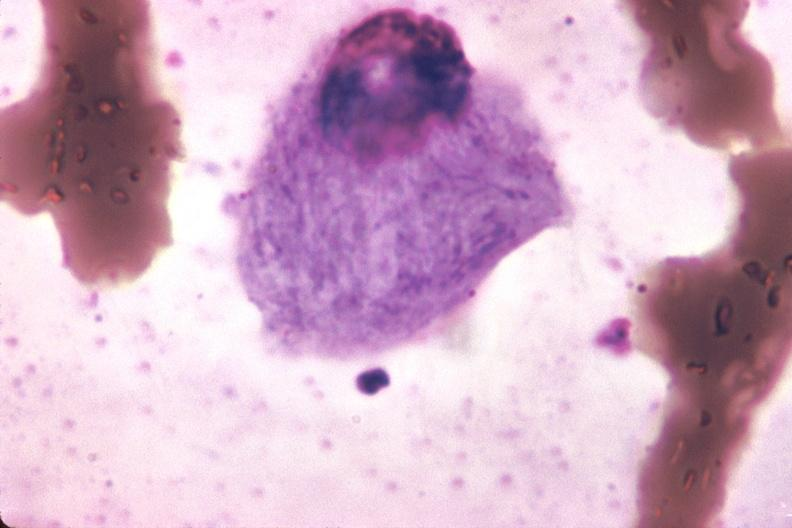what is present?
Answer the question using a single word or phrase. Bone marrow 